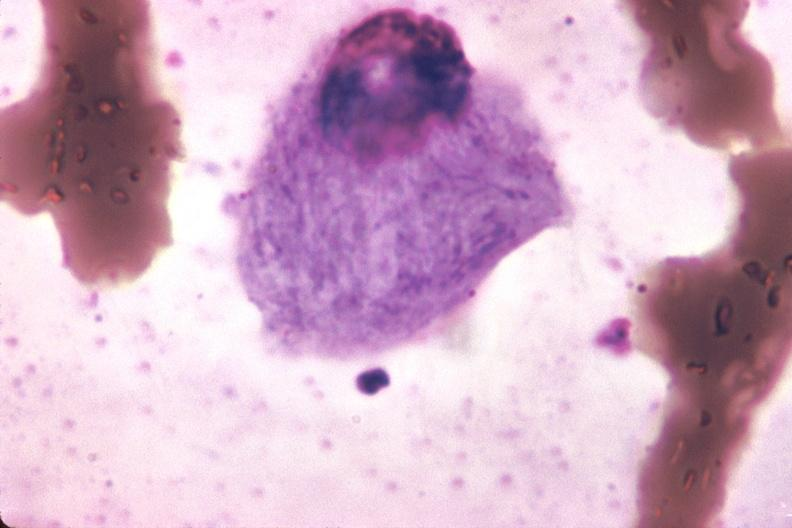what is present?
Answer the question using a single word or phrase. Bone marrow 